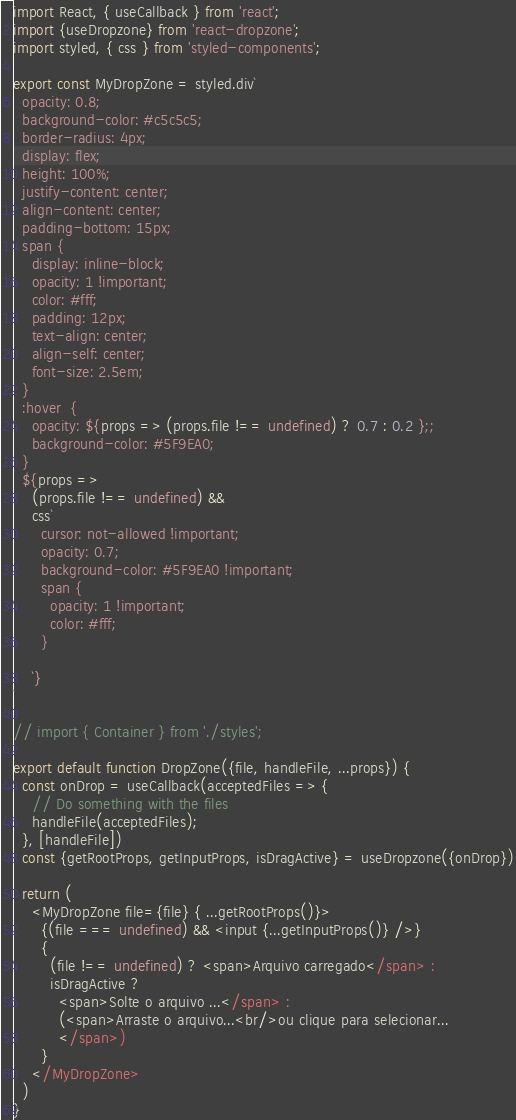<code> <loc_0><loc_0><loc_500><loc_500><_JavaScript_>import React, { useCallback } from 'react';
import {useDropzone} from 'react-dropzone';
import styled, { css } from 'styled-components';

export const MyDropZone = styled.div`
  opacity: 0.8;
  background-color: #c5c5c5;
  border-radius: 4px;
  display: flex;
  height: 100%;
  justify-content: center;
  align-content: center;
  padding-bottom: 15px;
  span {
    display: inline-block;
    opacity: 1 !important;
    color: #fff;
    padding: 12px;
    text-align: center;
    align-self: center;
    font-size: 2.5em;
  }
  :hover  {
    opacity: ${props => (props.file !== undefined) ? 0.7 : 0.2 };;
    background-color: #5F9EA0;
  }
  ${props =>
    (props.file !== undefined) &&
    css`
      cursor: not-allowed !important;
      opacity: 0.7;
      background-color: #5F9EA0 !important;
      span {
        opacity: 1 !important;
        color: #fff;
      }
      
    `}
`

// import { Container } from './styles';

export default function DropZone({file, handleFile, ...props}) {
  const onDrop = useCallback(acceptedFiles => {
    // Do something with the files
    handleFile(acceptedFiles);
  }, [handleFile])
  const {getRootProps, getInputProps, isDragActive} = useDropzone({onDrop})

  return (
    <MyDropZone file={file} { ...getRootProps()}>
      {(file === undefined) && <input {...getInputProps()} />}
      {
        (file !== undefined) ? <span>Arquivo carregado</span> :
        isDragActive ?
          <span>Solte o arquivo ...</span> :
          (<span>Arraste o arquivo...<br/>ou clique para selecionar...
          </span>)
      }
    </MyDropZone>
  )
}</code> 